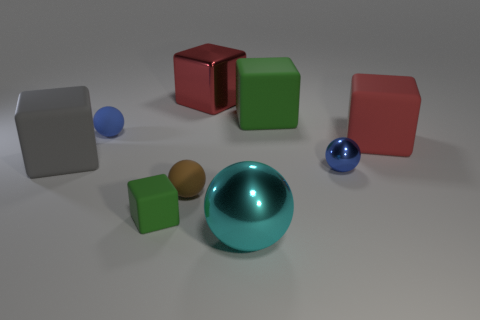How many other large balls have the same color as the big metallic ball?
Offer a very short reply. 0. There is a tiny thing that is behind the blue metallic thing; is it the same shape as the small brown object?
Offer a very short reply. Yes. There is a blue object that is left of the green matte object that is behind the green thing that is to the left of the large cyan metallic thing; what shape is it?
Give a very brief answer. Sphere. The brown sphere has what size?
Give a very brief answer. Small. There is a tiny sphere that is made of the same material as the big cyan ball; what color is it?
Your response must be concise. Blue. How many big yellow things have the same material as the big green object?
Make the answer very short. 0. Does the tiny rubber block have the same color as the big matte thing that is behind the blue rubber thing?
Your answer should be very brief. Yes. What color is the rubber sphere in front of the small blue object that is to the left of the big metal block?
Keep it short and to the point. Brown. The metal object that is the same size as the brown matte ball is what color?
Your response must be concise. Blue. Is there a red rubber object of the same shape as the big cyan thing?
Make the answer very short. No. 